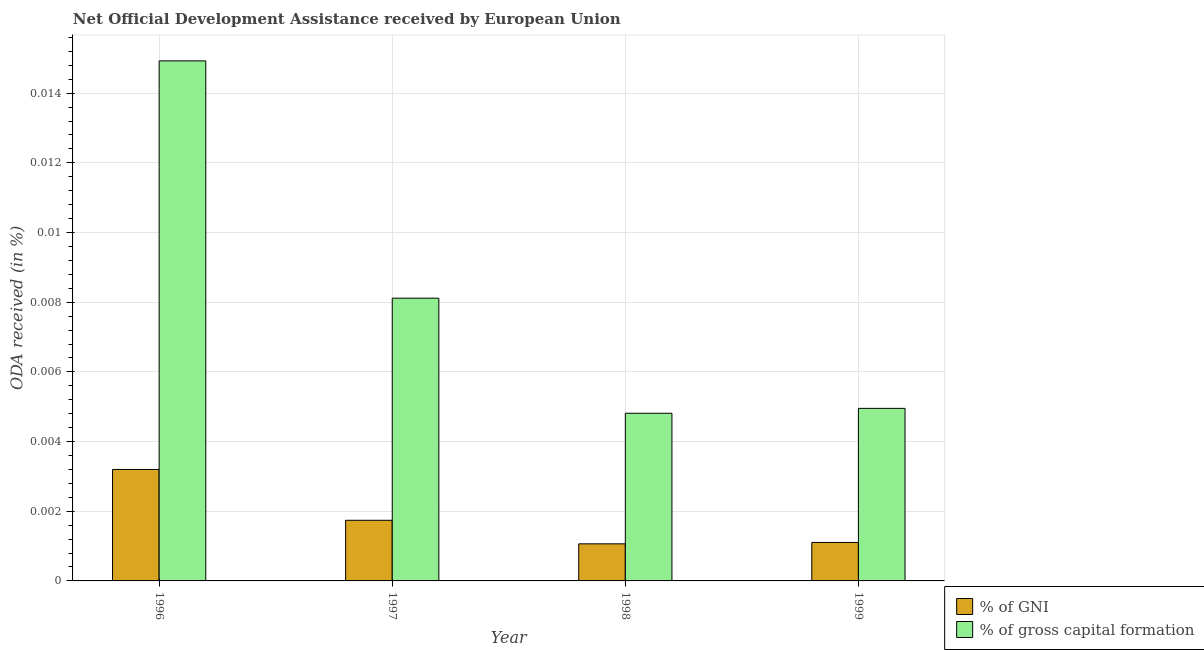Are the number of bars per tick equal to the number of legend labels?
Your answer should be compact. Yes. Are the number of bars on each tick of the X-axis equal?
Make the answer very short. Yes. How many bars are there on the 1st tick from the right?
Provide a short and direct response. 2. What is the oda received as percentage of gni in 1998?
Your answer should be compact. 0. Across all years, what is the maximum oda received as percentage of gni?
Give a very brief answer. 0. Across all years, what is the minimum oda received as percentage of gross capital formation?
Your answer should be compact. 0. In which year was the oda received as percentage of gross capital formation maximum?
Your response must be concise. 1996. What is the total oda received as percentage of gni in the graph?
Your answer should be very brief. 0.01. What is the difference between the oda received as percentage of gross capital formation in 1998 and that in 1999?
Provide a succinct answer. -0. What is the difference between the oda received as percentage of gni in 1997 and the oda received as percentage of gross capital formation in 1996?
Offer a very short reply. -0. What is the average oda received as percentage of gni per year?
Provide a succinct answer. 0. In the year 1999, what is the difference between the oda received as percentage of gni and oda received as percentage of gross capital formation?
Give a very brief answer. 0. What is the ratio of the oda received as percentage of gni in 1997 to that in 1998?
Provide a short and direct response. 1.63. What is the difference between the highest and the second highest oda received as percentage of gross capital formation?
Offer a very short reply. 0.01. What is the difference between the highest and the lowest oda received as percentage of gni?
Provide a short and direct response. 0. What does the 2nd bar from the left in 1998 represents?
Give a very brief answer. % of gross capital formation. What does the 1st bar from the right in 1997 represents?
Offer a very short reply. % of gross capital formation. How many bars are there?
Make the answer very short. 8. What is the difference between two consecutive major ticks on the Y-axis?
Keep it short and to the point. 0. How many legend labels are there?
Your answer should be compact. 2. How are the legend labels stacked?
Provide a short and direct response. Vertical. What is the title of the graph?
Keep it short and to the point. Net Official Development Assistance received by European Union. What is the label or title of the X-axis?
Keep it short and to the point. Year. What is the label or title of the Y-axis?
Your answer should be compact. ODA received (in %). What is the ODA received (in %) in % of GNI in 1996?
Ensure brevity in your answer.  0. What is the ODA received (in %) in % of gross capital formation in 1996?
Provide a short and direct response. 0.01. What is the ODA received (in %) in % of GNI in 1997?
Offer a terse response. 0. What is the ODA received (in %) of % of gross capital formation in 1997?
Your response must be concise. 0.01. What is the ODA received (in %) in % of GNI in 1998?
Keep it short and to the point. 0. What is the ODA received (in %) of % of gross capital formation in 1998?
Provide a short and direct response. 0. What is the ODA received (in %) of % of GNI in 1999?
Provide a succinct answer. 0. What is the ODA received (in %) in % of gross capital formation in 1999?
Make the answer very short. 0. Across all years, what is the maximum ODA received (in %) of % of GNI?
Give a very brief answer. 0. Across all years, what is the maximum ODA received (in %) of % of gross capital formation?
Offer a very short reply. 0.01. Across all years, what is the minimum ODA received (in %) in % of GNI?
Offer a very short reply. 0. Across all years, what is the minimum ODA received (in %) in % of gross capital formation?
Ensure brevity in your answer.  0. What is the total ODA received (in %) in % of GNI in the graph?
Keep it short and to the point. 0.01. What is the total ODA received (in %) of % of gross capital formation in the graph?
Provide a short and direct response. 0.03. What is the difference between the ODA received (in %) in % of GNI in 1996 and that in 1997?
Your answer should be very brief. 0. What is the difference between the ODA received (in %) in % of gross capital formation in 1996 and that in 1997?
Provide a short and direct response. 0.01. What is the difference between the ODA received (in %) in % of GNI in 1996 and that in 1998?
Make the answer very short. 0. What is the difference between the ODA received (in %) of % of gross capital formation in 1996 and that in 1998?
Keep it short and to the point. 0.01. What is the difference between the ODA received (in %) in % of GNI in 1996 and that in 1999?
Your response must be concise. 0. What is the difference between the ODA received (in %) of % of gross capital formation in 1996 and that in 1999?
Offer a very short reply. 0.01. What is the difference between the ODA received (in %) of % of GNI in 1997 and that in 1998?
Your response must be concise. 0. What is the difference between the ODA received (in %) in % of gross capital formation in 1997 and that in 1998?
Provide a succinct answer. 0. What is the difference between the ODA received (in %) of % of GNI in 1997 and that in 1999?
Provide a short and direct response. 0. What is the difference between the ODA received (in %) in % of gross capital formation in 1997 and that in 1999?
Keep it short and to the point. 0. What is the difference between the ODA received (in %) of % of gross capital formation in 1998 and that in 1999?
Provide a succinct answer. -0. What is the difference between the ODA received (in %) of % of GNI in 1996 and the ODA received (in %) of % of gross capital formation in 1997?
Provide a succinct answer. -0. What is the difference between the ODA received (in %) in % of GNI in 1996 and the ODA received (in %) in % of gross capital formation in 1998?
Offer a very short reply. -0. What is the difference between the ODA received (in %) of % of GNI in 1996 and the ODA received (in %) of % of gross capital formation in 1999?
Provide a succinct answer. -0. What is the difference between the ODA received (in %) in % of GNI in 1997 and the ODA received (in %) in % of gross capital formation in 1998?
Give a very brief answer. -0. What is the difference between the ODA received (in %) in % of GNI in 1997 and the ODA received (in %) in % of gross capital formation in 1999?
Your answer should be compact. -0. What is the difference between the ODA received (in %) in % of GNI in 1998 and the ODA received (in %) in % of gross capital formation in 1999?
Offer a very short reply. -0. What is the average ODA received (in %) in % of GNI per year?
Your answer should be very brief. 0. What is the average ODA received (in %) in % of gross capital formation per year?
Your answer should be very brief. 0.01. In the year 1996, what is the difference between the ODA received (in %) of % of GNI and ODA received (in %) of % of gross capital formation?
Give a very brief answer. -0.01. In the year 1997, what is the difference between the ODA received (in %) in % of GNI and ODA received (in %) in % of gross capital formation?
Make the answer very short. -0.01. In the year 1998, what is the difference between the ODA received (in %) in % of GNI and ODA received (in %) in % of gross capital formation?
Provide a succinct answer. -0. In the year 1999, what is the difference between the ODA received (in %) of % of GNI and ODA received (in %) of % of gross capital formation?
Provide a succinct answer. -0. What is the ratio of the ODA received (in %) of % of GNI in 1996 to that in 1997?
Give a very brief answer. 1.84. What is the ratio of the ODA received (in %) of % of gross capital formation in 1996 to that in 1997?
Ensure brevity in your answer.  1.84. What is the ratio of the ODA received (in %) of % of GNI in 1996 to that in 1998?
Offer a terse response. 3. What is the ratio of the ODA received (in %) of % of gross capital formation in 1996 to that in 1998?
Give a very brief answer. 3.1. What is the ratio of the ODA received (in %) of % of GNI in 1996 to that in 1999?
Ensure brevity in your answer.  2.9. What is the ratio of the ODA received (in %) of % of gross capital formation in 1996 to that in 1999?
Ensure brevity in your answer.  3.01. What is the ratio of the ODA received (in %) of % of GNI in 1997 to that in 1998?
Your answer should be compact. 1.63. What is the ratio of the ODA received (in %) of % of gross capital formation in 1997 to that in 1998?
Your response must be concise. 1.69. What is the ratio of the ODA received (in %) in % of GNI in 1997 to that in 1999?
Provide a short and direct response. 1.58. What is the ratio of the ODA received (in %) in % of gross capital formation in 1997 to that in 1999?
Offer a terse response. 1.64. What is the ratio of the ODA received (in %) in % of GNI in 1998 to that in 1999?
Provide a short and direct response. 0.96. What is the ratio of the ODA received (in %) of % of gross capital formation in 1998 to that in 1999?
Offer a terse response. 0.97. What is the difference between the highest and the second highest ODA received (in %) in % of GNI?
Provide a short and direct response. 0. What is the difference between the highest and the second highest ODA received (in %) in % of gross capital formation?
Your answer should be compact. 0.01. What is the difference between the highest and the lowest ODA received (in %) of % of GNI?
Keep it short and to the point. 0. What is the difference between the highest and the lowest ODA received (in %) of % of gross capital formation?
Provide a succinct answer. 0.01. 